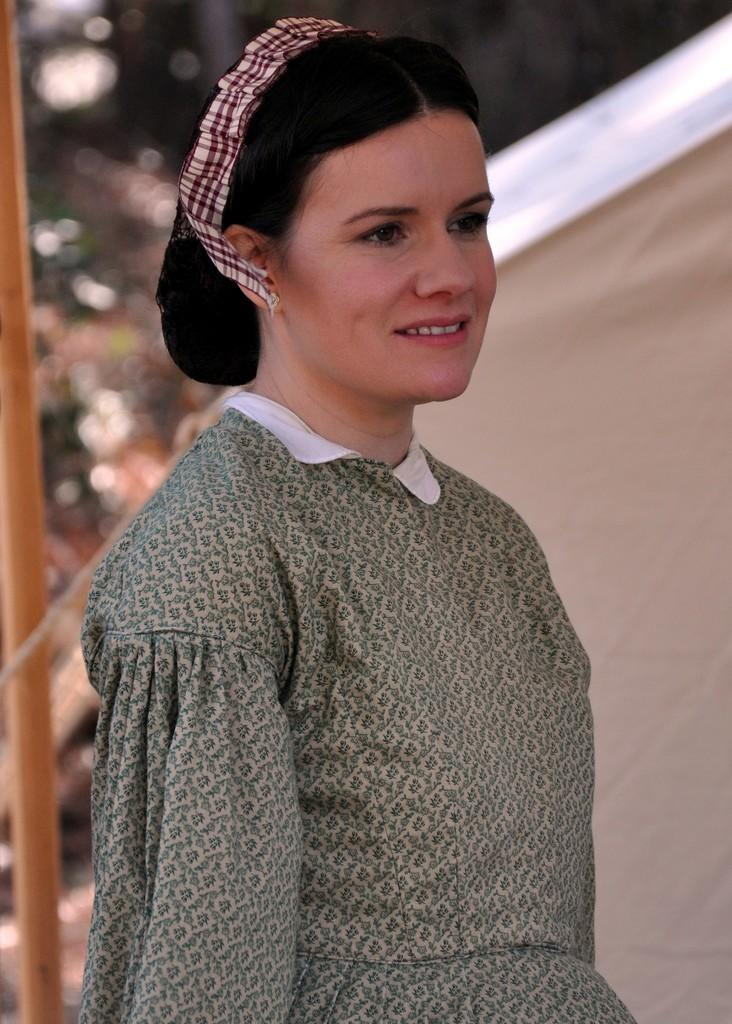Who is present in the image? There is a woman in the image. What is the woman doing in the image? The woman is smiling in the image. What can be seen in the background of the image? There is a tent visible in the background of the image. What is the woman wearing on her head? The woman has a ribbon on her head. What color is the woman's sock in the image? There is no mention of a sock in the image, so we cannot determine its color. 